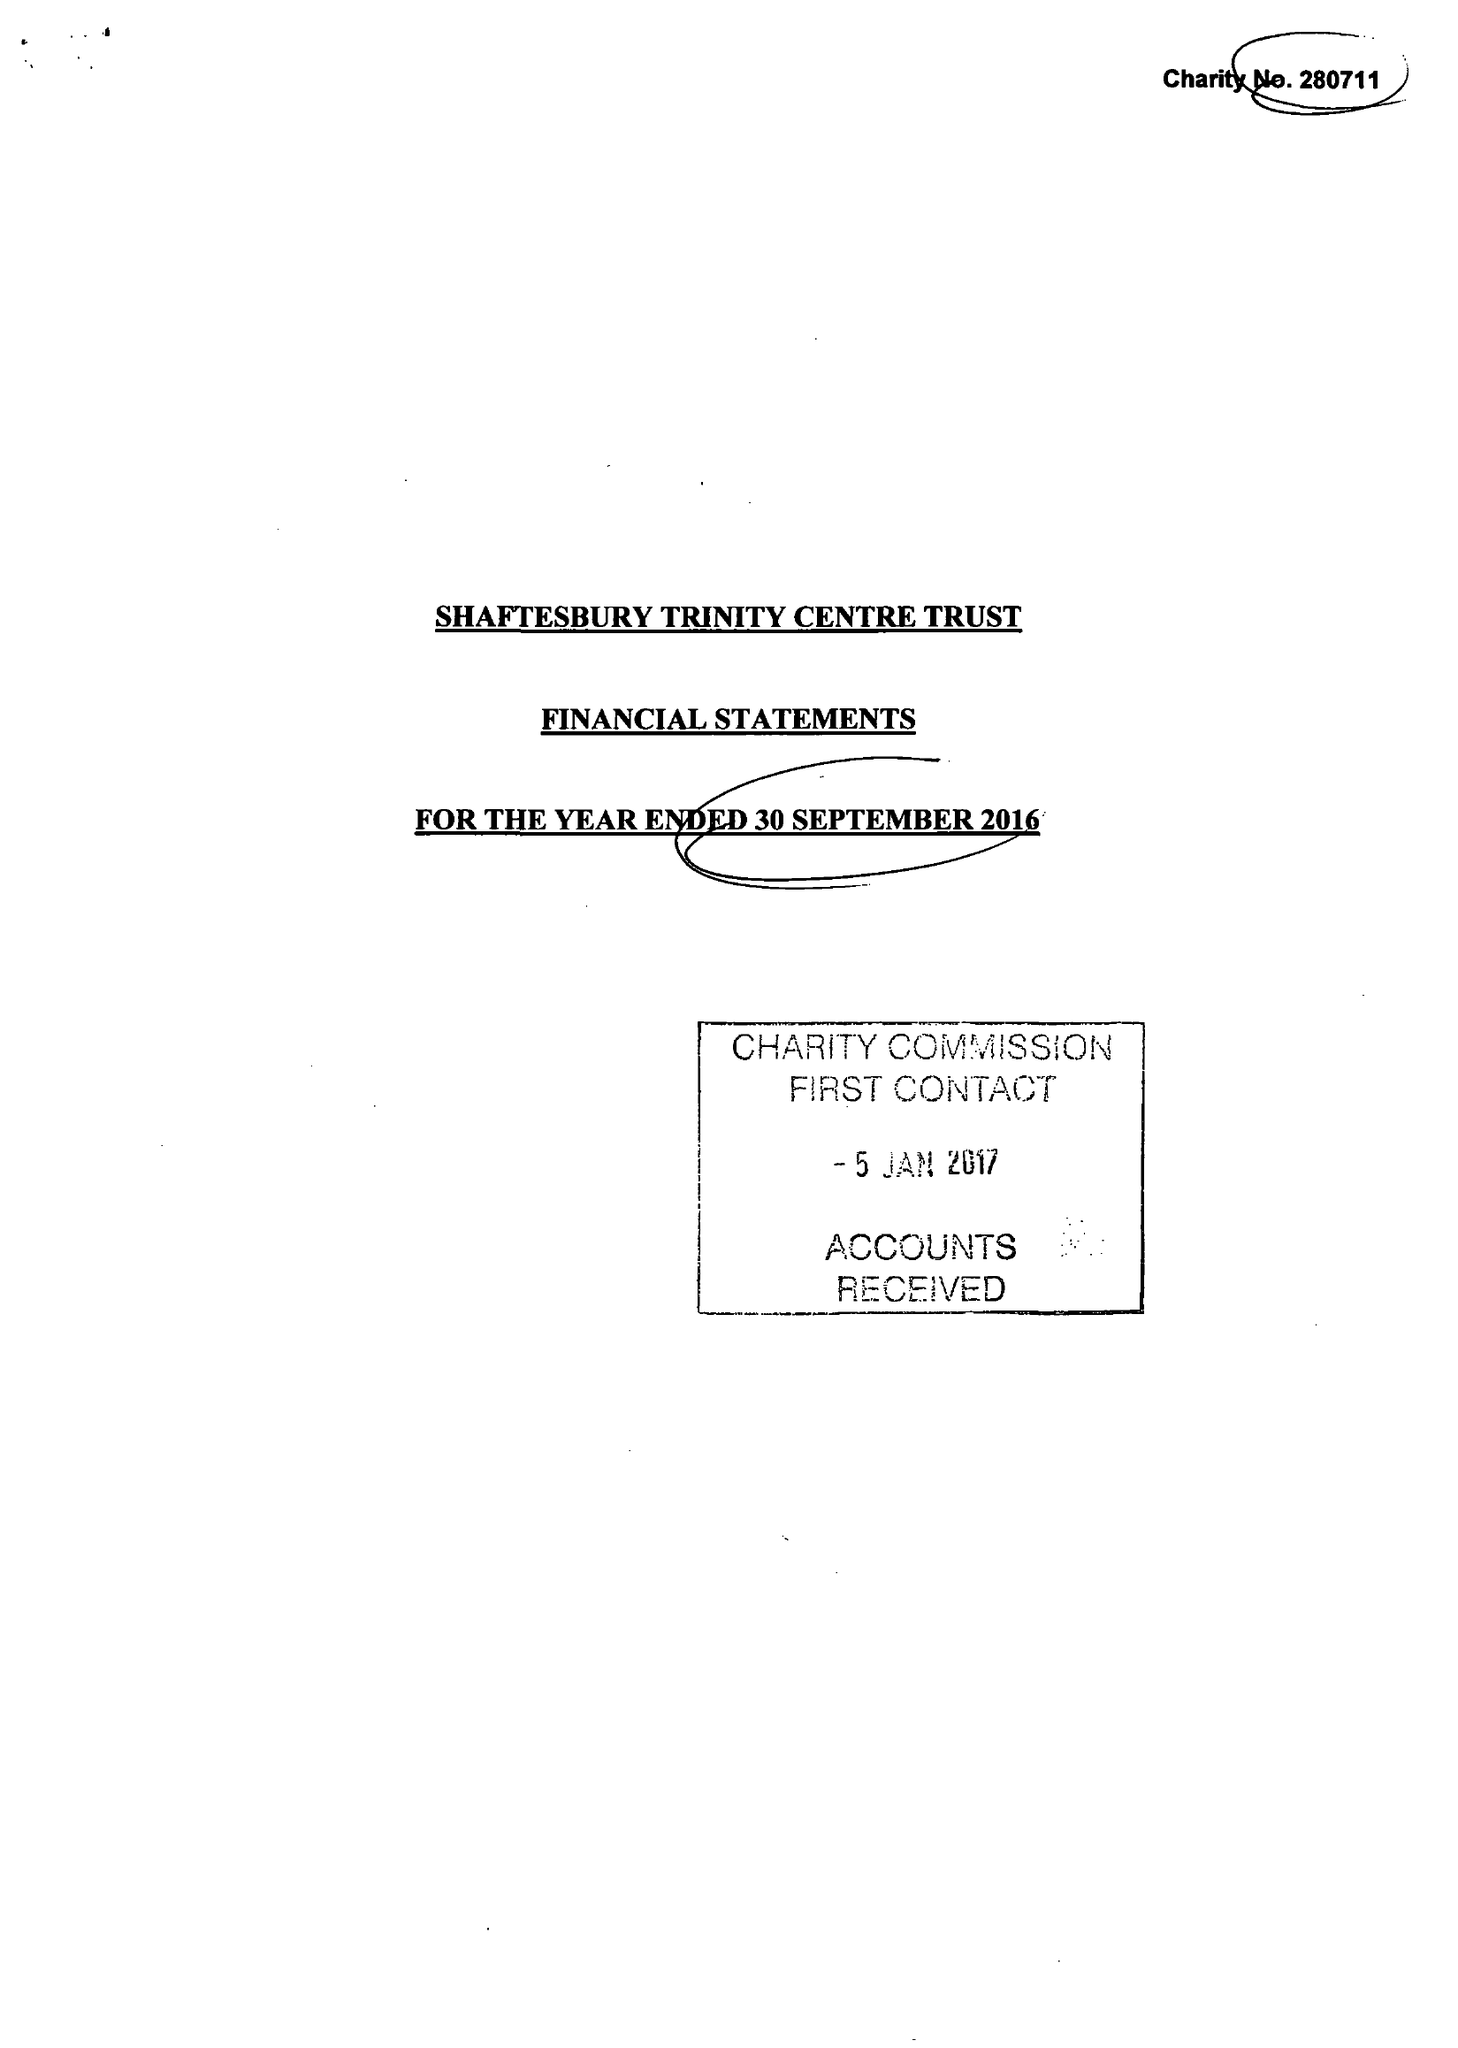What is the value for the address__street_line?
Answer the question using a single word or phrase. None 